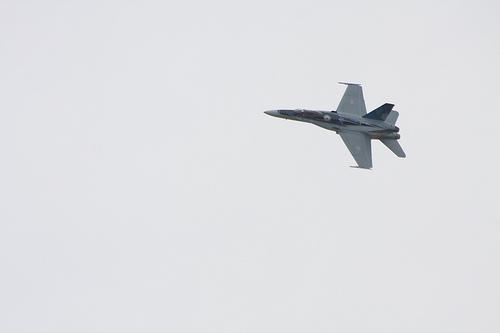How many planes are there?
Give a very brief answer. 1. 